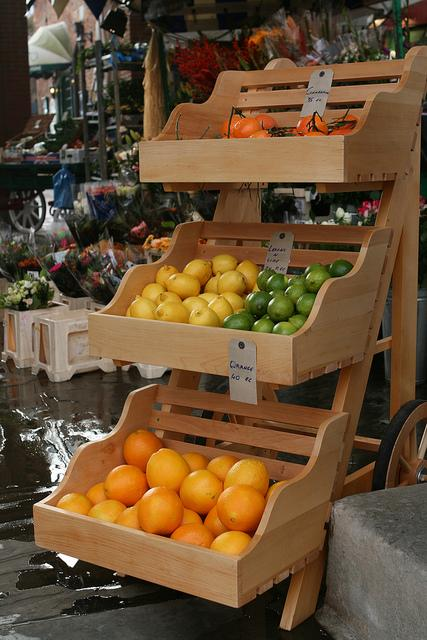The fruits in the raised wooden baskets seen here are all what?

Choices:
A) citrus
B) apples
C) cherries
D) melons citrus 